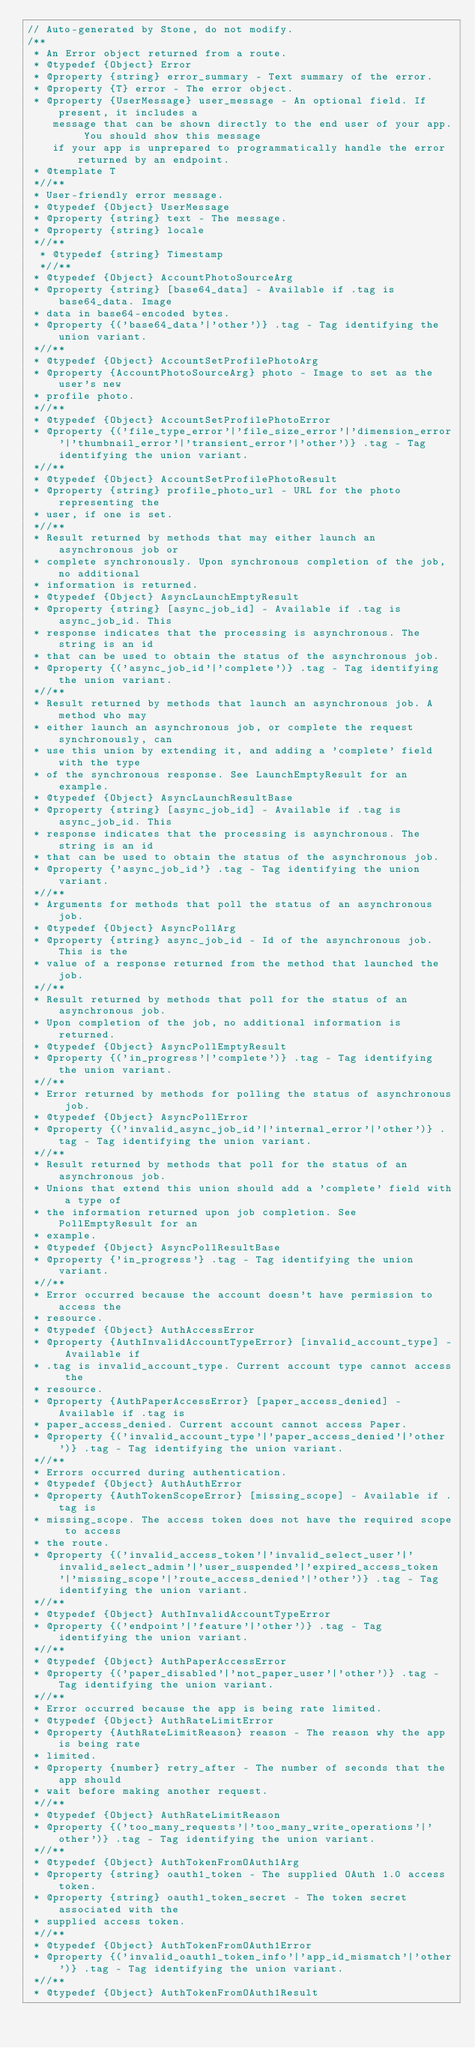<code> <loc_0><loc_0><loc_500><loc_500><_JavaScript_>// Auto-generated by Stone, do not modify.
/**
 * An Error object returned from a route.
 * @typedef {Object} Error
 * @property {string} error_summary - Text summary of the error.
 * @property {T} error - The error object.
 * @property {UserMessage} user_message - An optional field. If present, it includes a
    message that can be shown directly to the end user of your app. You should show this message
    if your app is unprepared to programmatically handle the error returned by an endpoint.
 * @template T
 *//**
 * User-friendly error message.
 * @typedef {Object} UserMessage
 * @property {string} text - The message.
 * @property {string} locale
 *//**
  * @typedef {string} Timestamp
  *//**
 * @typedef {Object} AccountPhotoSourceArg
 * @property {string} [base64_data] - Available if .tag is base64_data. Image
 * data in base64-encoded bytes.
 * @property {('base64_data'|'other')} .tag - Tag identifying the union variant.
 *//**
 * @typedef {Object} AccountSetProfilePhotoArg
 * @property {AccountPhotoSourceArg} photo - Image to set as the user's new
 * profile photo.
 *//**
 * @typedef {Object} AccountSetProfilePhotoError
 * @property {('file_type_error'|'file_size_error'|'dimension_error'|'thumbnail_error'|'transient_error'|'other')} .tag - Tag identifying the union variant.
 *//**
 * @typedef {Object} AccountSetProfilePhotoResult
 * @property {string} profile_photo_url - URL for the photo representing the
 * user, if one is set.
 *//**
 * Result returned by methods that may either launch an asynchronous job or
 * complete synchronously. Upon synchronous completion of the job, no additional
 * information is returned.
 * @typedef {Object} AsyncLaunchEmptyResult
 * @property {string} [async_job_id] - Available if .tag is async_job_id. This
 * response indicates that the processing is asynchronous. The string is an id
 * that can be used to obtain the status of the asynchronous job.
 * @property {('async_job_id'|'complete')} .tag - Tag identifying the union variant.
 *//**
 * Result returned by methods that launch an asynchronous job. A method who may
 * either launch an asynchronous job, or complete the request synchronously, can
 * use this union by extending it, and adding a 'complete' field with the type
 * of the synchronous response. See LaunchEmptyResult for an example.
 * @typedef {Object} AsyncLaunchResultBase
 * @property {string} [async_job_id] - Available if .tag is async_job_id. This
 * response indicates that the processing is asynchronous. The string is an id
 * that can be used to obtain the status of the asynchronous job.
 * @property {'async_job_id'} .tag - Tag identifying the union variant.
 *//**
 * Arguments for methods that poll the status of an asynchronous job.
 * @typedef {Object} AsyncPollArg
 * @property {string} async_job_id - Id of the asynchronous job. This is the
 * value of a response returned from the method that launched the job.
 *//**
 * Result returned by methods that poll for the status of an asynchronous job.
 * Upon completion of the job, no additional information is returned.
 * @typedef {Object} AsyncPollEmptyResult
 * @property {('in_progress'|'complete')} .tag - Tag identifying the union variant.
 *//**
 * Error returned by methods for polling the status of asynchronous job.
 * @typedef {Object} AsyncPollError
 * @property {('invalid_async_job_id'|'internal_error'|'other')} .tag - Tag identifying the union variant.
 *//**
 * Result returned by methods that poll for the status of an asynchronous job.
 * Unions that extend this union should add a 'complete' field with a type of
 * the information returned upon job completion. See PollEmptyResult for an
 * example.
 * @typedef {Object} AsyncPollResultBase
 * @property {'in_progress'} .tag - Tag identifying the union variant.
 *//**
 * Error occurred because the account doesn't have permission to access the
 * resource.
 * @typedef {Object} AuthAccessError
 * @property {AuthInvalidAccountTypeError} [invalid_account_type] - Available if
 * .tag is invalid_account_type. Current account type cannot access the
 * resource.
 * @property {AuthPaperAccessError} [paper_access_denied] - Available if .tag is
 * paper_access_denied. Current account cannot access Paper.
 * @property {('invalid_account_type'|'paper_access_denied'|'other')} .tag - Tag identifying the union variant.
 *//**
 * Errors occurred during authentication.
 * @typedef {Object} AuthAuthError
 * @property {AuthTokenScopeError} [missing_scope] - Available if .tag is
 * missing_scope. The access token does not have the required scope to access
 * the route.
 * @property {('invalid_access_token'|'invalid_select_user'|'invalid_select_admin'|'user_suspended'|'expired_access_token'|'missing_scope'|'route_access_denied'|'other')} .tag - Tag identifying the union variant.
 *//**
 * @typedef {Object} AuthInvalidAccountTypeError
 * @property {('endpoint'|'feature'|'other')} .tag - Tag identifying the union variant.
 *//**
 * @typedef {Object} AuthPaperAccessError
 * @property {('paper_disabled'|'not_paper_user'|'other')} .tag - Tag identifying the union variant.
 *//**
 * Error occurred because the app is being rate limited.
 * @typedef {Object} AuthRateLimitError
 * @property {AuthRateLimitReason} reason - The reason why the app is being rate
 * limited.
 * @property {number} retry_after - The number of seconds that the app should
 * wait before making another request.
 *//**
 * @typedef {Object} AuthRateLimitReason
 * @property {('too_many_requests'|'too_many_write_operations'|'other')} .tag - Tag identifying the union variant.
 *//**
 * @typedef {Object} AuthTokenFromOAuth1Arg
 * @property {string} oauth1_token - The supplied OAuth 1.0 access token.
 * @property {string} oauth1_token_secret - The token secret associated with the
 * supplied access token.
 *//**
 * @typedef {Object} AuthTokenFromOAuth1Error
 * @property {('invalid_oauth1_token_info'|'app_id_mismatch'|'other')} .tag - Tag identifying the union variant.
 *//**
 * @typedef {Object} AuthTokenFromOAuth1Result</code> 